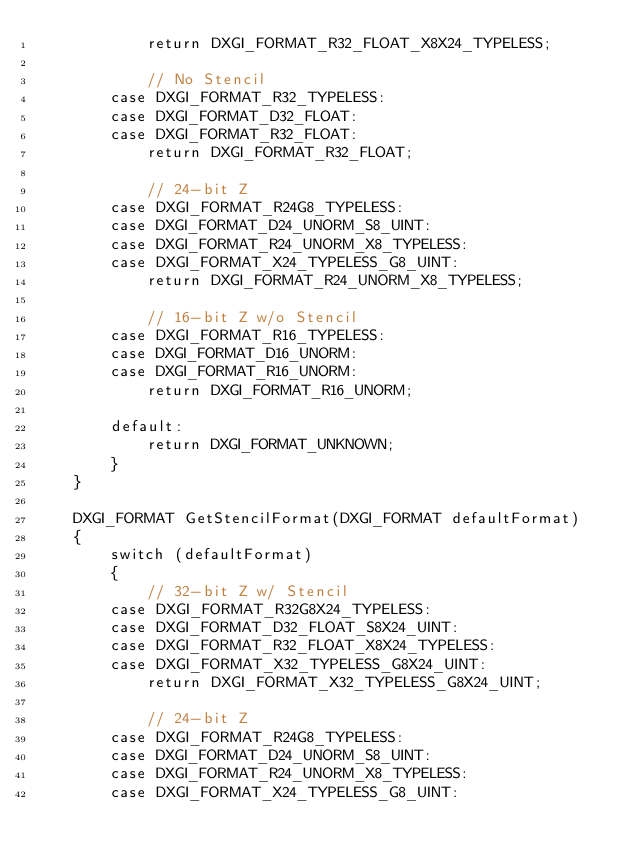<code> <loc_0><loc_0><loc_500><loc_500><_ObjectiveC_>            return DXGI_FORMAT_R32_FLOAT_X8X24_TYPELESS;

            // No Stencil
        case DXGI_FORMAT_R32_TYPELESS:
        case DXGI_FORMAT_D32_FLOAT:
        case DXGI_FORMAT_R32_FLOAT:
            return DXGI_FORMAT_R32_FLOAT;

            // 24-bit Z
        case DXGI_FORMAT_R24G8_TYPELESS:
        case DXGI_FORMAT_D24_UNORM_S8_UINT:
        case DXGI_FORMAT_R24_UNORM_X8_TYPELESS:
        case DXGI_FORMAT_X24_TYPELESS_G8_UINT:
            return DXGI_FORMAT_R24_UNORM_X8_TYPELESS;

            // 16-bit Z w/o Stencil
        case DXGI_FORMAT_R16_TYPELESS:
        case DXGI_FORMAT_D16_UNORM:
        case DXGI_FORMAT_R16_UNORM:
            return DXGI_FORMAT_R16_UNORM;

        default:
            return DXGI_FORMAT_UNKNOWN;
        }
    }

    DXGI_FORMAT GetStencilFormat(DXGI_FORMAT defaultFormat)
    {
        switch (defaultFormat)
        {
            // 32-bit Z w/ Stencil
        case DXGI_FORMAT_R32G8X24_TYPELESS:
        case DXGI_FORMAT_D32_FLOAT_S8X24_UINT:
        case DXGI_FORMAT_R32_FLOAT_X8X24_TYPELESS:
        case DXGI_FORMAT_X32_TYPELESS_G8X24_UINT:
            return DXGI_FORMAT_X32_TYPELESS_G8X24_UINT;

            // 24-bit Z
        case DXGI_FORMAT_R24G8_TYPELESS:
        case DXGI_FORMAT_D24_UNORM_S8_UINT:
        case DXGI_FORMAT_R24_UNORM_X8_TYPELESS:
        case DXGI_FORMAT_X24_TYPELESS_G8_UINT:</code> 